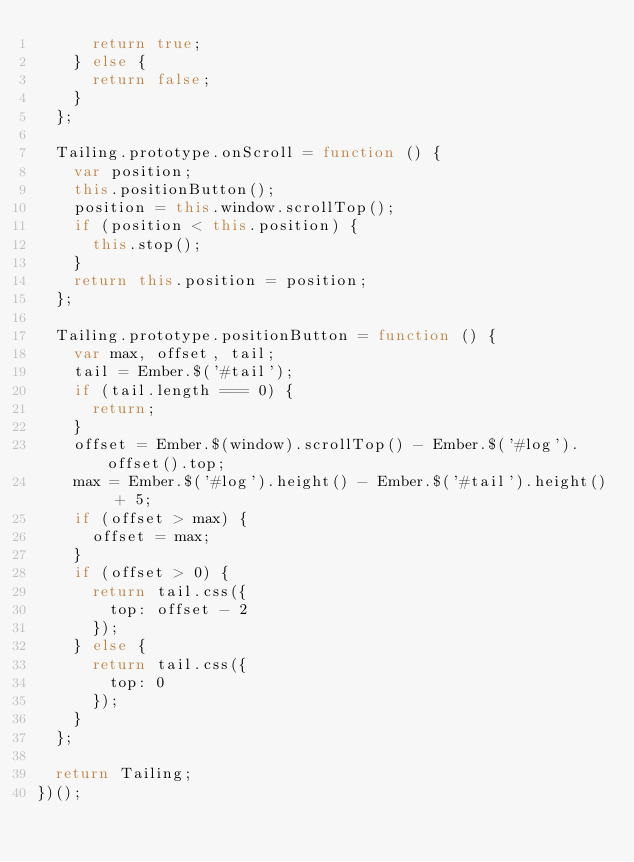Convert code to text. <code><loc_0><loc_0><loc_500><loc_500><_JavaScript_>      return true;
    } else {
      return false;
    }
  };

  Tailing.prototype.onScroll = function () {
    var position;
    this.positionButton();
    position = this.window.scrollTop();
    if (position < this.position) {
      this.stop();
    }
    return this.position = position;
  };

  Tailing.prototype.positionButton = function () {
    var max, offset, tail;
    tail = Ember.$('#tail');
    if (tail.length === 0) {
      return;
    }
    offset = Ember.$(window).scrollTop() - Ember.$('#log').offset().top;
    max = Ember.$('#log').height() - Ember.$('#tail').height() + 5;
    if (offset > max) {
      offset = max;
    }
    if (offset > 0) {
      return tail.css({
        top: offset - 2
      });
    } else {
      return tail.css({
        top: 0
      });
    }
  };

  return Tailing;
})();
</code> 